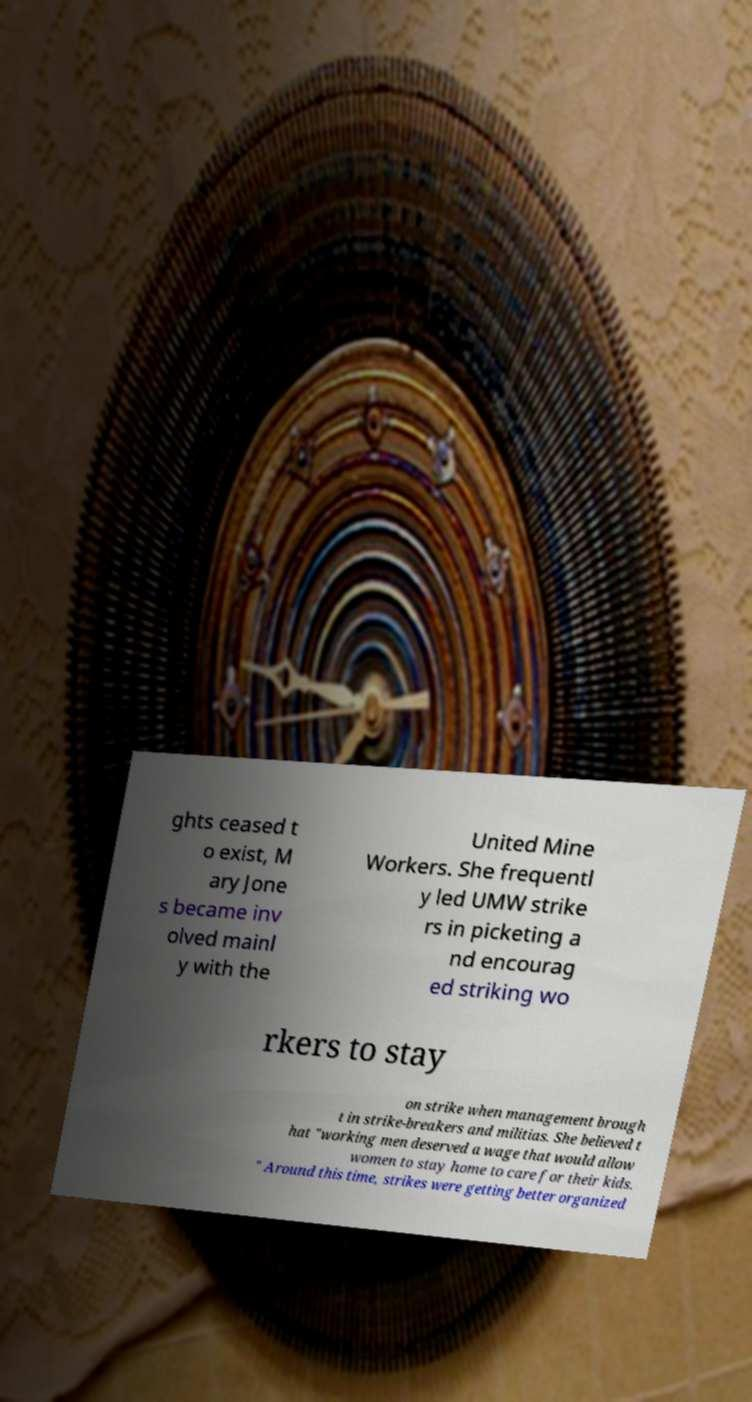Please read and relay the text visible in this image. What does it say? ghts ceased t o exist, M ary Jone s became inv olved mainl y with the United Mine Workers. She frequentl y led UMW strike rs in picketing a nd encourag ed striking wo rkers to stay on strike when management brough t in strike-breakers and militias. She believed t hat "working men deserved a wage that would allow women to stay home to care for their kids. " Around this time, strikes were getting better organized 